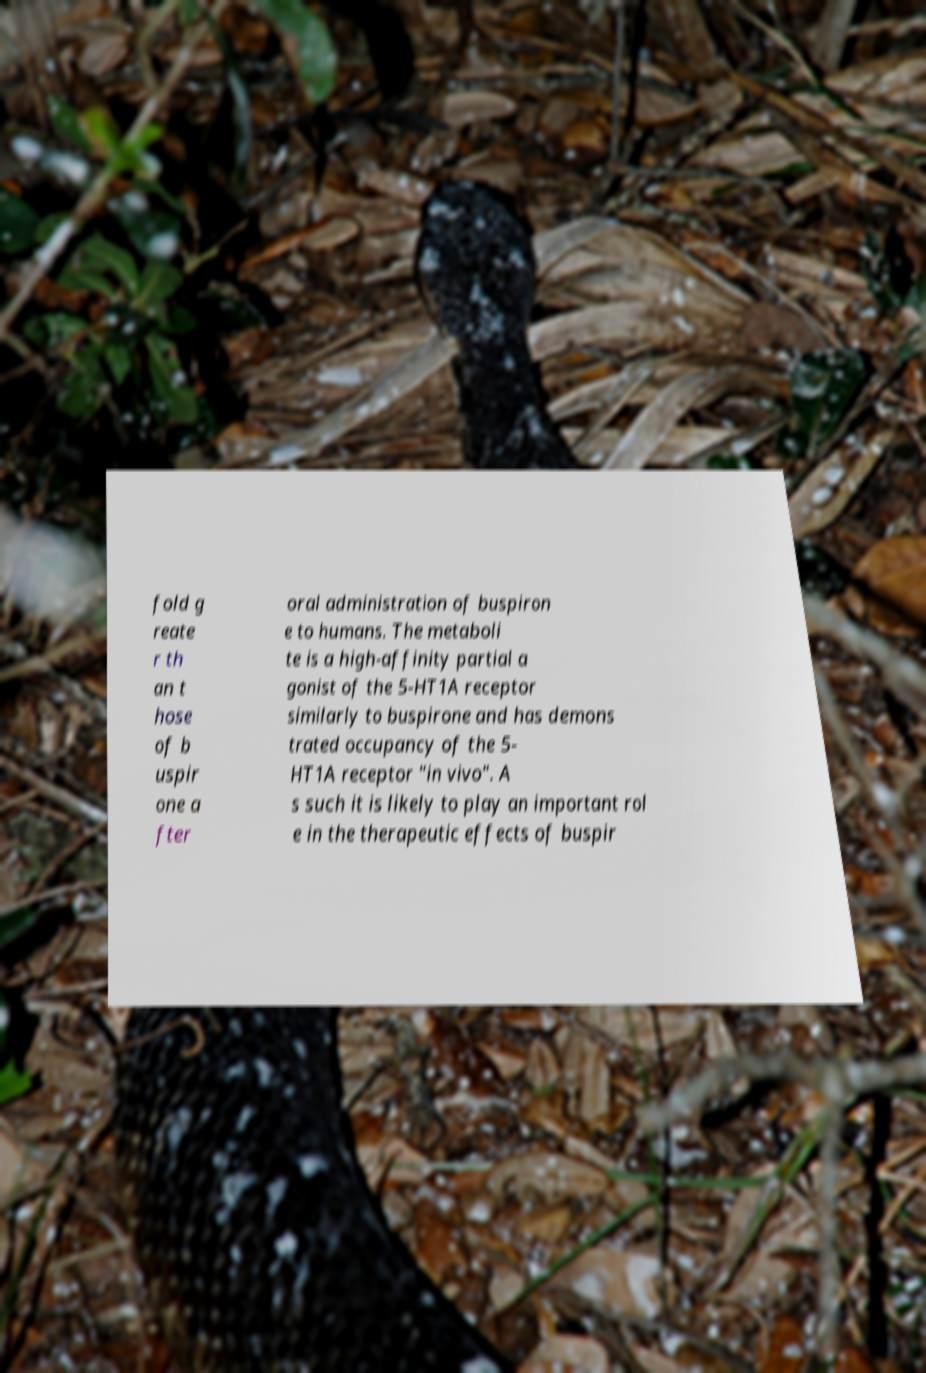For documentation purposes, I need the text within this image transcribed. Could you provide that? fold g reate r th an t hose of b uspir one a fter oral administration of buspiron e to humans. The metaboli te is a high-affinity partial a gonist of the 5-HT1A receptor similarly to buspirone and has demons trated occupancy of the 5- HT1A receptor "in vivo". A s such it is likely to play an important rol e in the therapeutic effects of buspir 